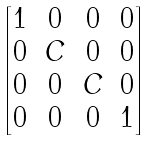Convert formula to latex. <formula><loc_0><loc_0><loc_500><loc_500>\begin{bmatrix} 1 & 0 & 0 & 0 \\ 0 & C & 0 & 0 \\ 0 & 0 & C & 0 \\ 0 & 0 & 0 & 1 \end{bmatrix}</formula> 